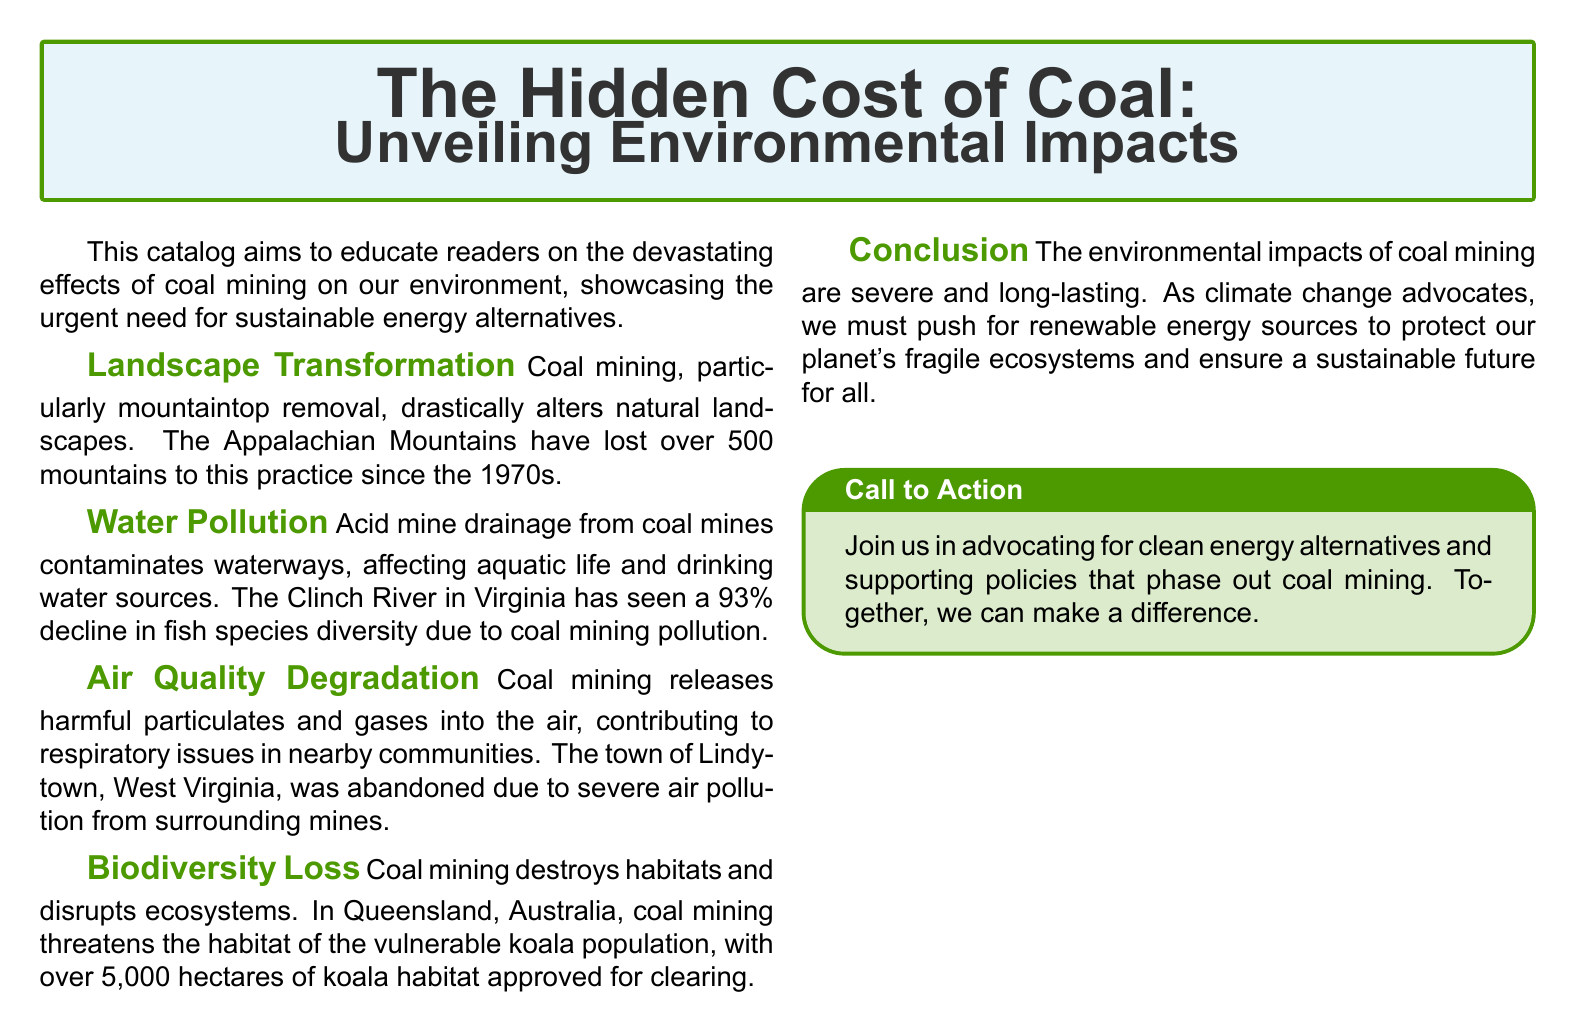What is the title of the catalog? The title of the catalog is prominently displayed at the beginning and is "The Hidden Cost of Coal: Unveiling Environmental Impacts."
Answer: The Hidden Cost of Coal: Unveiling Environmental Impacts How many mountains have been lost due to coal mining since the 1970s? The document states that over 500 mountains have been lost since the 1970s due to coal mining practices.
Answer: 500 What major river is mentioned in relation to coal mining pollution? The Clinch River in Virginia is specifically mentioned regarding the decline in fish species diversity due to coal mining.
Answer: Clinch River What percentage decline did fish species diversity experience in the Clinch River? The document states that fish species diversity in the Clinch River has experienced a 93% decline due to coal mining pollution.
Answer: 93% Which animal's habitat is threatened by coal mining in Queensland? The document refers to the vulnerable koala population whose habitat is threatened by coal mining in Queensland, Australia.
Answer: Koala What is one major consequence of air quality degradation from coal mining? The document highlights respiratory issues in nearby communities as a major consequence of air quality degradation caused by coal mining.
Answer: Respiratory issues What type of mining is mentioned as drastically altering landscapes? The document specifies mountaintop removal as the type of mining that drastically alters natural landscapes.
Answer: Mountaintop removal What is the overall conclusion regarding the impact of coal mining? The conclusion in the document emphasizes that the environmental impacts of coal mining are severe and long-lasting, advocating for renewable energy sources.
Answer: Severe and long-lasting What is the call to action in the catalog? The call to action encourages advocacy for clean energy alternatives and support for policies to phase out coal mining.
Answer: Advocate for clean energy alternatives 